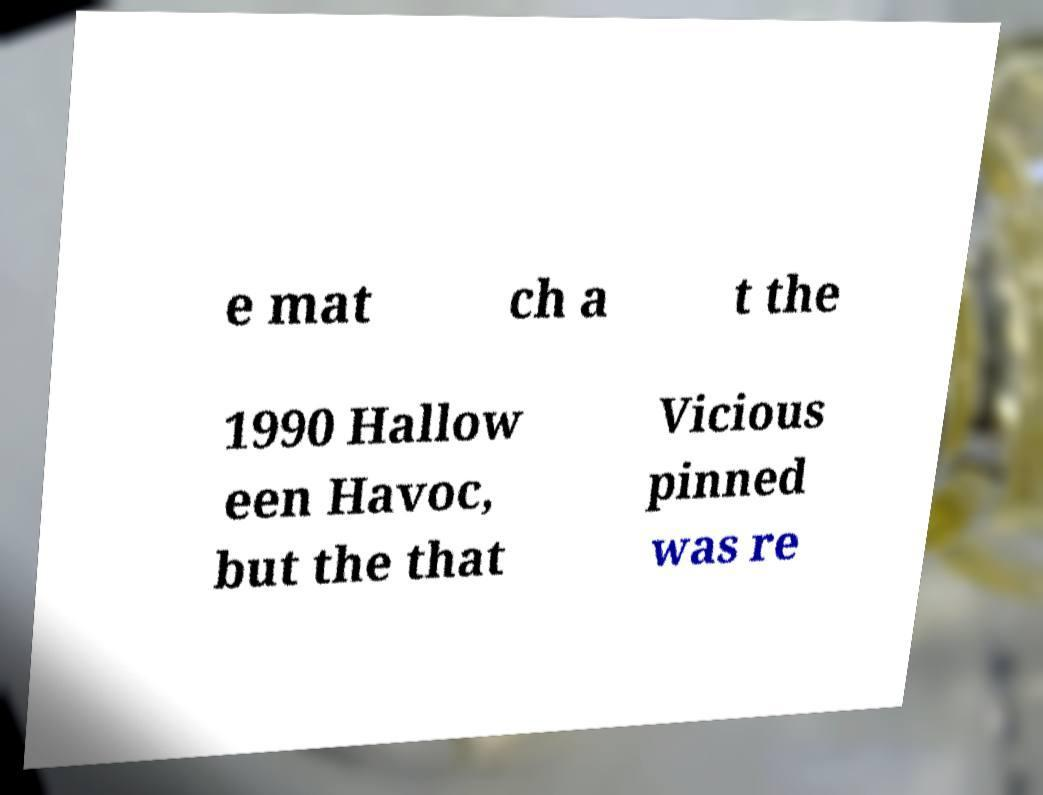What messages or text are displayed in this image? I need them in a readable, typed format. e mat ch a t the 1990 Hallow een Havoc, but the that Vicious pinned was re 